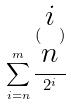Convert formula to latex. <formula><loc_0><loc_0><loc_500><loc_500>\sum _ { i = n } ^ { m } \frac { ( \begin{matrix} i \\ n \end{matrix} ) } { 2 ^ { i } }</formula> 